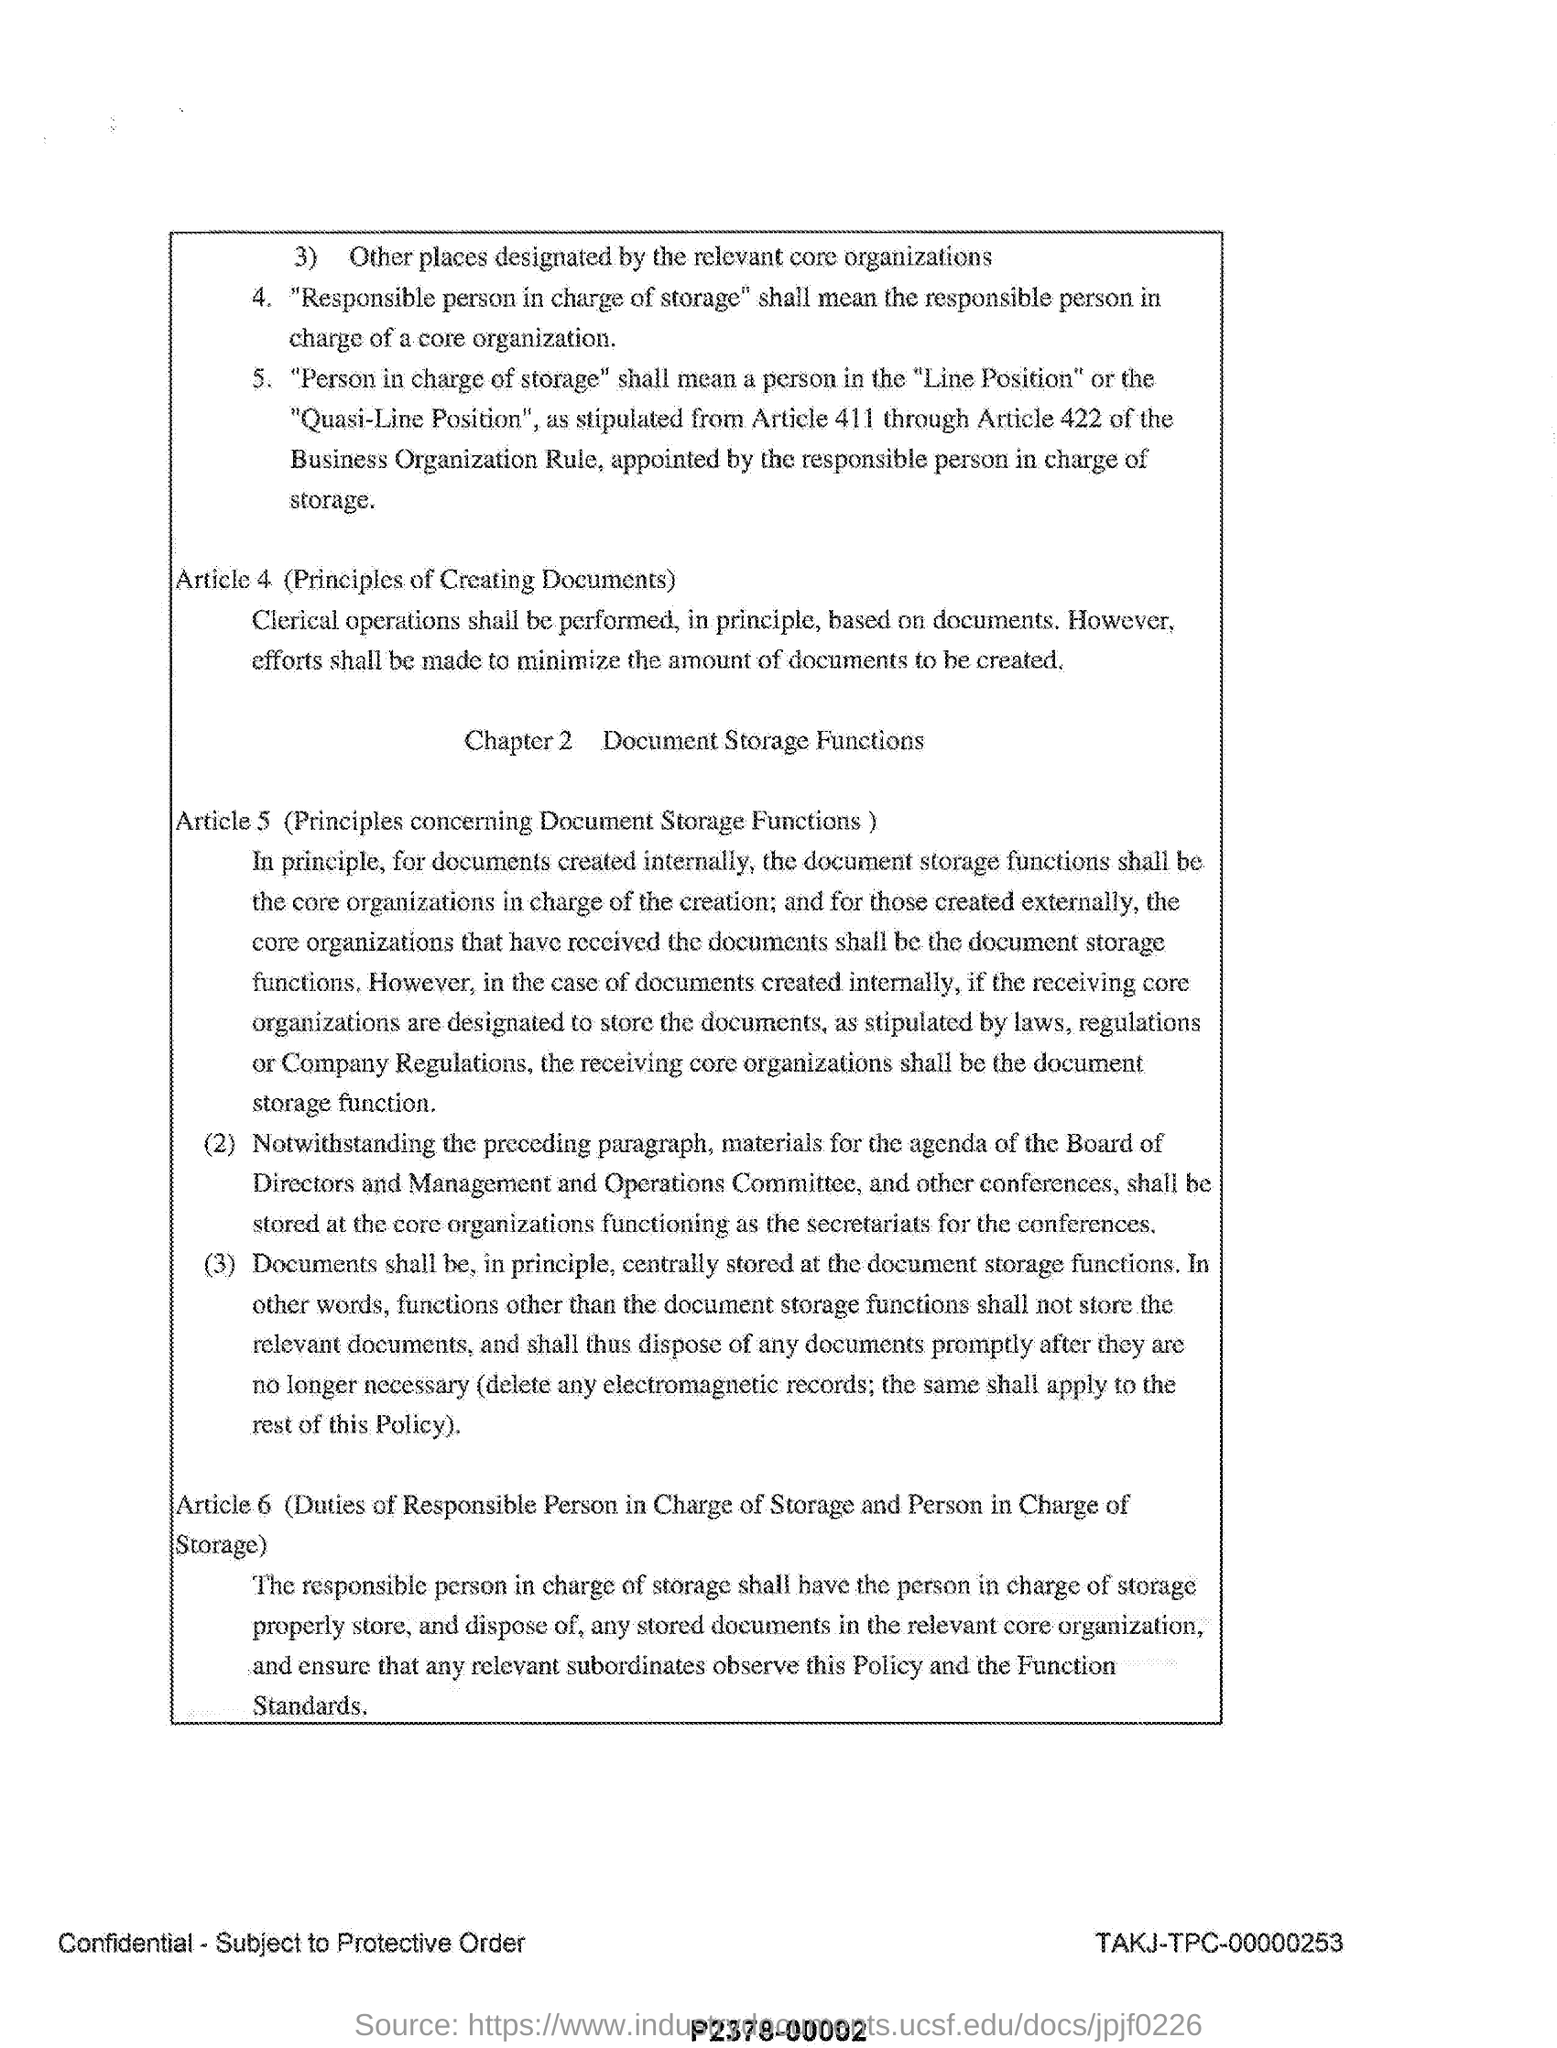Outline some significant characteristics in this image. Article 6 imposes duties on the responsible person in charge of storage and the person in charge of storage. Article 4 refers to the principles of creating documents. The title of Chapter 2 is 'Document Storage Functions'. Article 5 of this document describes principles concerning document storage functions. 